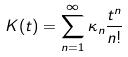<formula> <loc_0><loc_0><loc_500><loc_500>K ( t ) = \sum _ { n = 1 } ^ { \infty } \kappa _ { n } \frac { t ^ { n } } { n ! }</formula> 